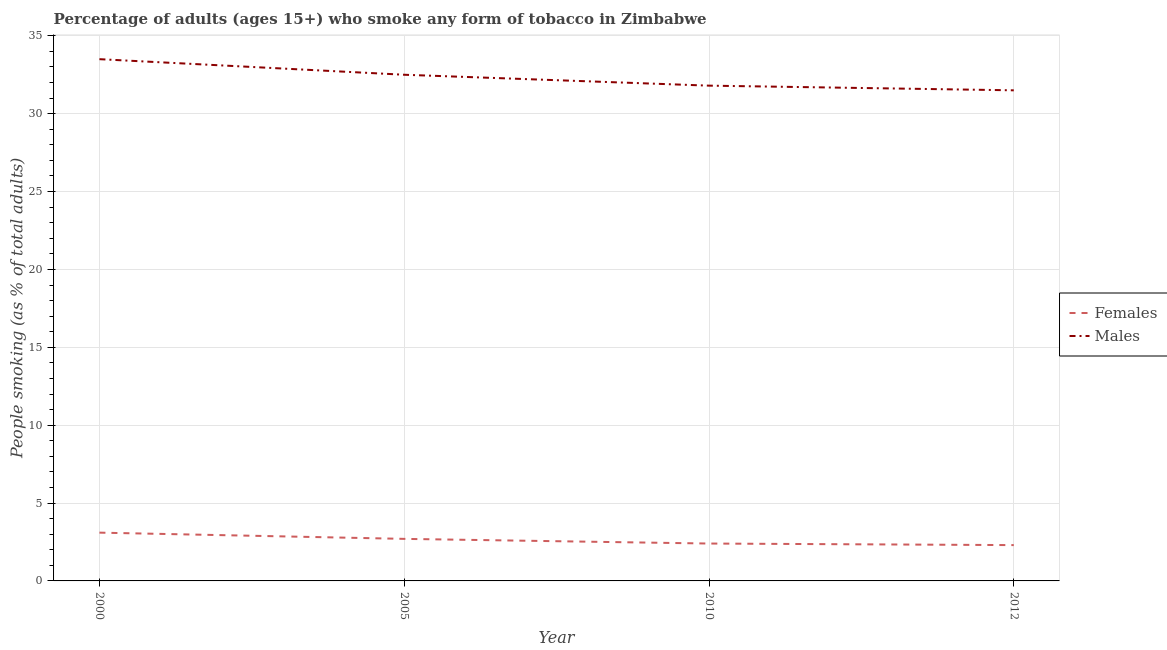How many different coloured lines are there?
Give a very brief answer. 2. Does the line corresponding to percentage of males who smoke intersect with the line corresponding to percentage of females who smoke?
Give a very brief answer. No. Is the number of lines equal to the number of legend labels?
Provide a succinct answer. Yes. What is the percentage of males who smoke in 2012?
Offer a very short reply. 31.5. Across all years, what is the maximum percentage of males who smoke?
Offer a very short reply. 33.5. What is the total percentage of females who smoke in the graph?
Offer a very short reply. 10.5. What is the difference between the percentage of females who smoke in 2000 and that in 2012?
Your response must be concise. 0.8. What is the difference between the percentage of males who smoke in 2010 and the percentage of females who smoke in 2000?
Provide a succinct answer. 28.7. What is the average percentage of males who smoke per year?
Make the answer very short. 32.33. In the year 2000, what is the difference between the percentage of males who smoke and percentage of females who smoke?
Your answer should be compact. 30.4. In how many years, is the percentage of females who smoke greater than 9 %?
Your answer should be very brief. 0. What is the ratio of the percentage of males who smoke in 2000 to that in 2012?
Your response must be concise. 1.06. Is the percentage of males who smoke in 2000 less than that in 2012?
Give a very brief answer. No. Is the difference between the percentage of males who smoke in 2000 and 2005 greater than the difference between the percentage of females who smoke in 2000 and 2005?
Your answer should be compact. Yes. What is the difference between the highest and the second highest percentage of males who smoke?
Your answer should be very brief. 1. In how many years, is the percentage of females who smoke greater than the average percentage of females who smoke taken over all years?
Provide a succinct answer. 2. Is the sum of the percentage of males who smoke in 2005 and 2010 greater than the maximum percentage of females who smoke across all years?
Give a very brief answer. Yes. Is the percentage of females who smoke strictly greater than the percentage of males who smoke over the years?
Provide a short and direct response. No. Is the percentage of males who smoke strictly less than the percentage of females who smoke over the years?
Your answer should be very brief. No. How many lines are there?
Offer a terse response. 2. Does the graph contain grids?
Ensure brevity in your answer.  Yes. Where does the legend appear in the graph?
Your response must be concise. Center right. How are the legend labels stacked?
Your answer should be very brief. Vertical. What is the title of the graph?
Give a very brief answer. Percentage of adults (ages 15+) who smoke any form of tobacco in Zimbabwe. What is the label or title of the Y-axis?
Provide a succinct answer. People smoking (as % of total adults). What is the People smoking (as % of total adults) of Females in 2000?
Offer a terse response. 3.1. What is the People smoking (as % of total adults) in Males in 2000?
Provide a short and direct response. 33.5. What is the People smoking (as % of total adults) of Females in 2005?
Keep it short and to the point. 2.7. What is the People smoking (as % of total adults) of Males in 2005?
Offer a terse response. 32.5. What is the People smoking (as % of total adults) in Males in 2010?
Your answer should be very brief. 31.8. What is the People smoking (as % of total adults) of Males in 2012?
Provide a succinct answer. 31.5. Across all years, what is the maximum People smoking (as % of total adults) of Females?
Your response must be concise. 3.1. Across all years, what is the maximum People smoking (as % of total adults) of Males?
Your response must be concise. 33.5. Across all years, what is the minimum People smoking (as % of total adults) in Males?
Your response must be concise. 31.5. What is the total People smoking (as % of total adults) in Males in the graph?
Provide a succinct answer. 129.3. What is the difference between the People smoking (as % of total adults) of Females in 2000 and that in 2005?
Your answer should be very brief. 0.4. What is the difference between the People smoking (as % of total adults) of Males in 2000 and that in 2005?
Your answer should be very brief. 1. What is the difference between the People smoking (as % of total adults) in Females in 2000 and that in 2012?
Offer a terse response. 0.8. What is the difference between the People smoking (as % of total adults) of Females in 2005 and that in 2010?
Provide a short and direct response. 0.3. What is the difference between the People smoking (as % of total adults) of Females in 2005 and that in 2012?
Make the answer very short. 0.4. What is the difference between the People smoking (as % of total adults) of Females in 2010 and that in 2012?
Provide a short and direct response. 0.1. What is the difference between the People smoking (as % of total adults) of Males in 2010 and that in 2012?
Provide a succinct answer. 0.3. What is the difference between the People smoking (as % of total adults) in Females in 2000 and the People smoking (as % of total adults) in Males in 2005?
Provide a short and direct response. -29.4. What is the difference between the People smoking (as % of total adults) of Females in 2000 and the People smoking (as % of total adults) of Males in 2010?
Give a very brief answer. -28.7. What is the difference between the People smoking (as % of total adults) in Females in 2000 and the People smoking (as % of total adults) in Males in 2012?
Provide a short and direct response. -28.4. What is the difference between the People smoking (as % of total adults) of Females in 2005 and the People smoking (as % of total adults) of Males in 2010?
Your answer should be very brief. -29.1. What is the difference between the People smoking (as % of total adults) of Females in 2005 and the People smoking (as % of total adults) of Males in 2012?
Your answer should be very brief. -28.8. What is the difference between the People smoking (as % of total adults) of Females in 2010 and the People smoking (as % of total adults) of Males in 2012?
Offer a very short reply. -29.1. What is the average People smoking (as % of total adults) in Females per year?
Make the answer very short. 2.62. What is the average People smoking (as % of total adults) of Males per year?
Your answer should be very brief. 32.33. In the year 2000, what is the difference between the People smoking (as % of total adults) in Females and People smoking (as % of total adults) in Males?
Provide a succinct answer. -30.4. In the year 2005, what is the difference between the People smoking (as % of total adults) in Females and People smoking (as % of total adults) in Males?
Your response must be concise. -29.8. In the year 2010, what is the difference between the People smoking (as % of total adults) in Females and People smoking (as % of total adults) in Males?
Ensure brevity in your answer.  -29.4. In the year 2012, what is the difference between the People smoking (as % of total adults) in Females and People smoking (as % of total adults) in Males?
Your response must be concise. -29.2. What is the ratio of the People smoking (as % of total adults) of Females in 2000 to that in 2005?
Offer a very short reply. 1.15. What is the ratio of the People smoking (as % of total adults) of Males in 2000 to that in 2005?
Give a very brief answer. 1.03. What is the ratio of the People smoking (as % of total adults) in Females in 2000 to that in 2010?
Make the answer very short. 1.29. What is the ratio of the People smoking (as % of total adults) of Males in 2000 to that in 2010?
Your answer should be compact. 1.05. What is the ratio of the People smoking (as % of total adults) in Females in 2000 to that in 2012?
Offer a very short reply. 1.35. What is the ratio of the People smoking (as % of total adults) of Males in 2000 to that in 2012?
Give a very brief answer. 1.06. What is the ratio of the People smoking (as % of total adults) in Females in 2005 to that in 2010?
Give a very brief answer. 1.12. What is the ratio of the People smoking (as % of total adults) in Males in 2005 to that in 2010?
Your answer should be compact. 1.02. What is the ratio of the People smoking (as % of total adults) in Females in 2005 to that in 2012?
Your answer should be very brief. 1.17. What is the ratio of the People smoking (as % of total adults) in Males in 2005 to that in 2012?
Keep it short and to the point. 1.03. What is the ratio of the People smoking (as % of total adults) of Females in 2010 to that in 2012?
Your answer should be compact. 1.04. What is the ratio of the People smoking (as % of total adults) of Males in 2010 to that in 2012?
Your answer should be very brief. 1.01. What is the difference between the highest and the lowest People smoking (as % of total adults) in Males?
Provide a succinct answer. 2. 